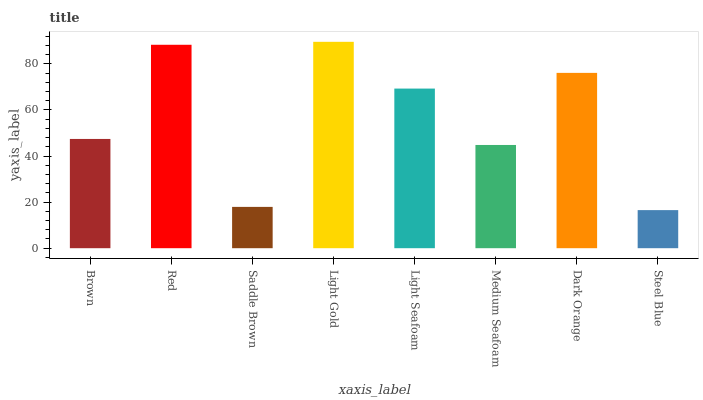Is Steel Blue the minimum?
Answer yes or no. Yes. Is Light Gold the maximum?
Answer yes or no. Yes. Is Red the minimum?
Answer yes or no. No. Is Red the maximum?
Answer yes or no. No. Is Red greater than Brown?
Answer yes or no. Yes. Is Brown less than Red?
Answer yes or no. Yes. Is Brown greater than Red?
Answer yes or no. No. Is Red less than Brown?
Answer yes or no. No. Is Light Seafoam the high median?
Answer yes or no. Yes. Is Brown the low median?
Answer yes or no. Yes. Is Medium Seafoam the high median?
Answer yes or no. No. Is Light Gold the low median?
Answer yes or no. No. 